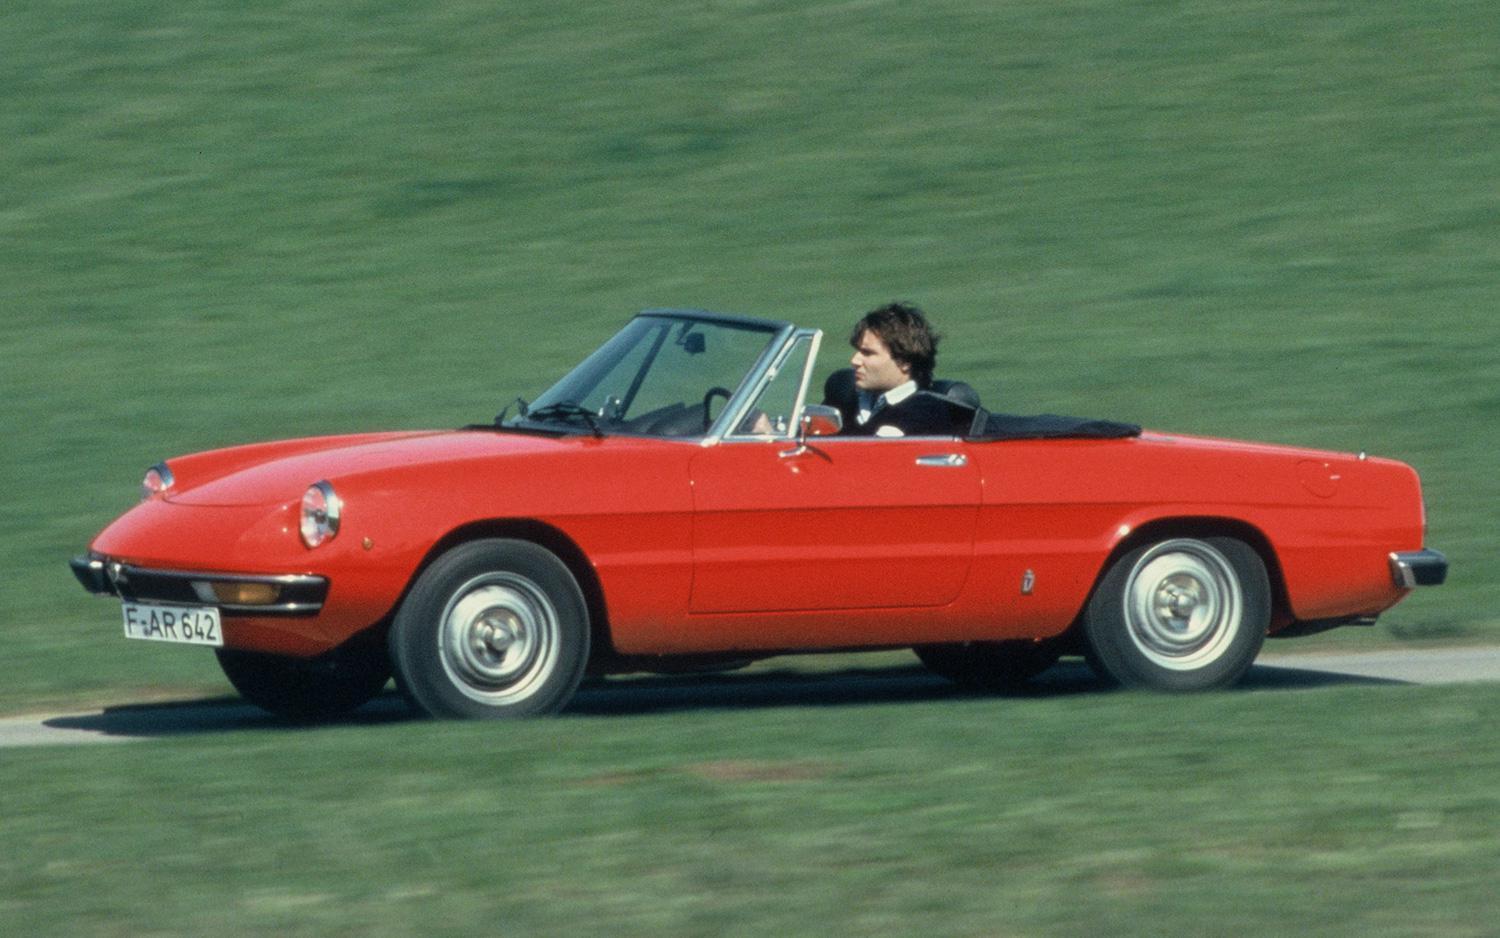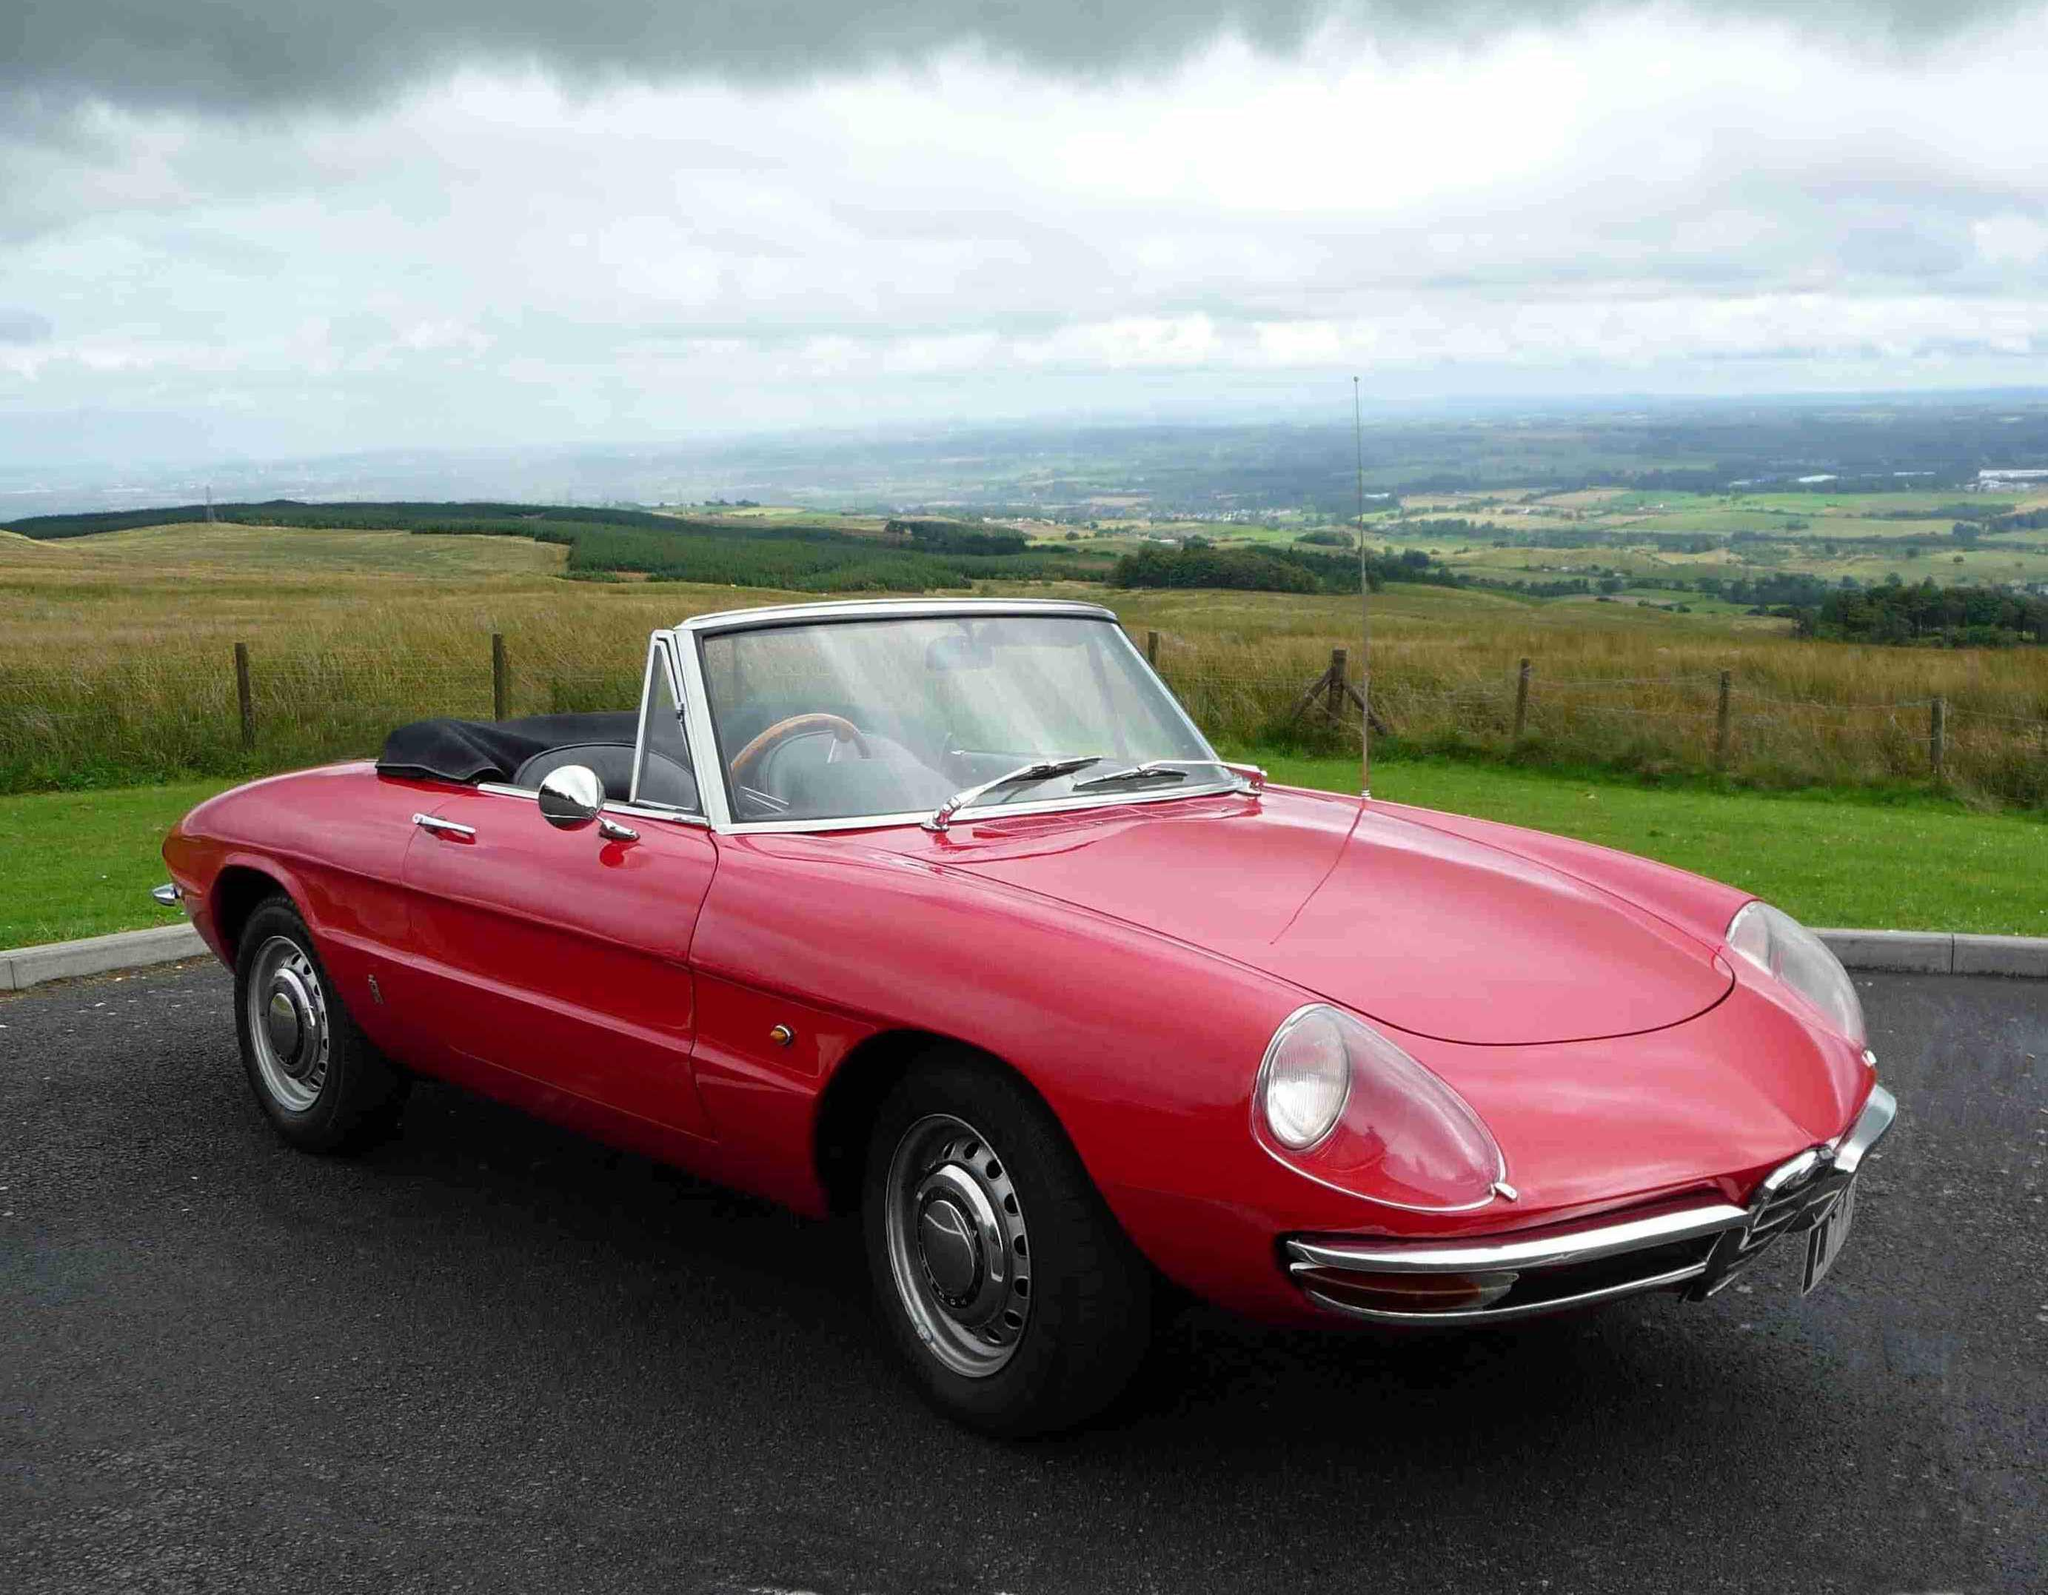The first image is the image on the left, the second image is the image on the right. For the images displayed, is the sentence "The left image shows a driver behind the wheel of a topless red convertible." factually correct? Answer yes or no. Yes. The first image is the image on the left, the second image is the image on the right. Evaluate the accuracy of this statement regarding the images: "Two sporty red convertibles with chrome wheels are angled in different directions, only one with a front license plate and driver.". Is it true? Answer yes or no. Yes. 